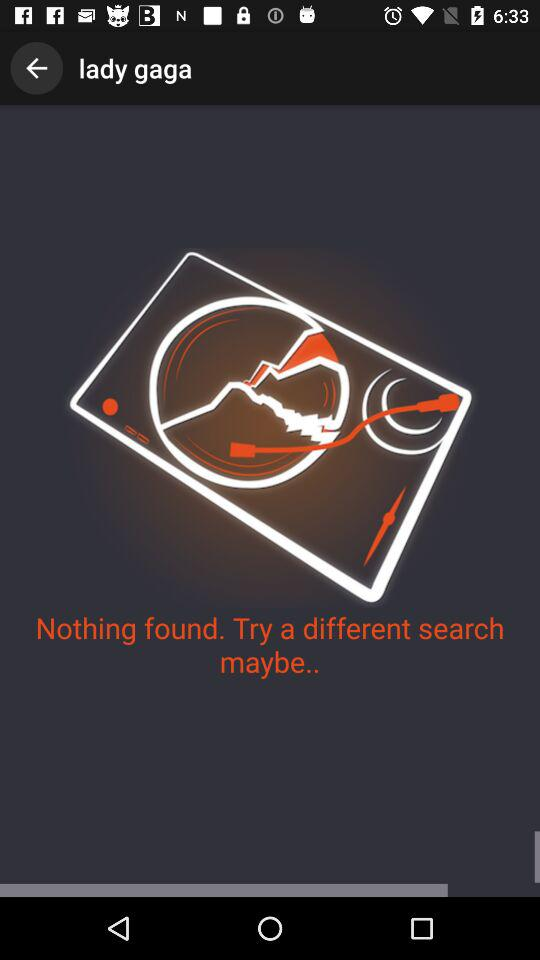Is anything found on searching? There is nothing found on searching. 